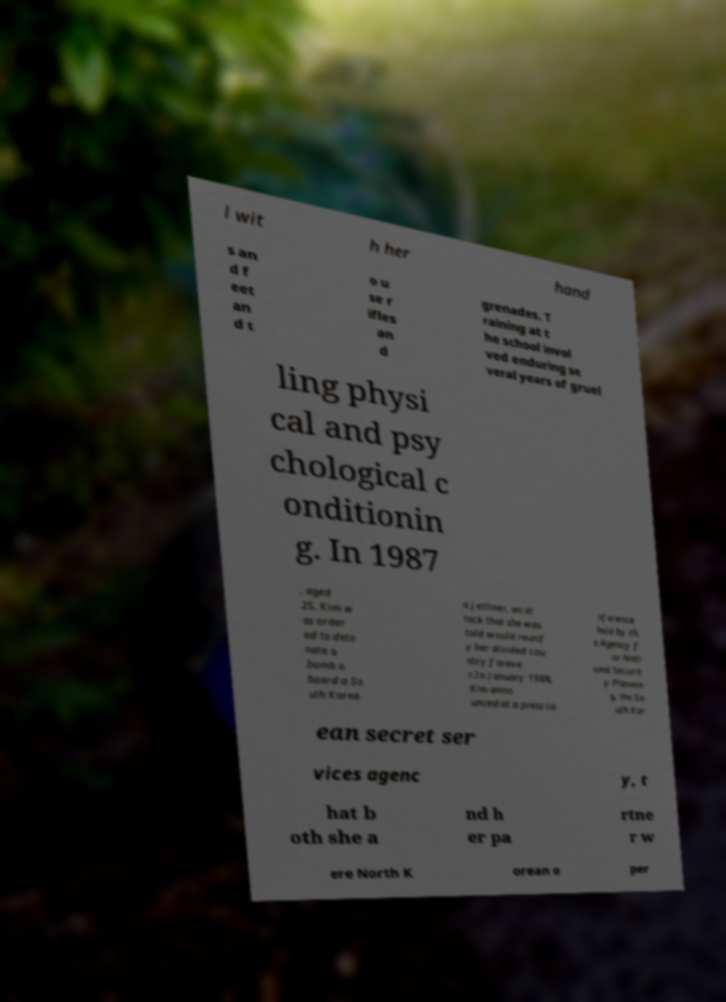I need the written content from this picture converted into text. Can you do that? l wit h her hand s an d f eet an d t o u se r ifles an d grenades. T raining at t he school invol ved enduring se veral years of gruel ling physi cal and psy chological c onditionin g. In 1987 , aged 25, Kim w as order ed to deto nate a bomb a board a So uth Korea n jetliner, an at tack that she was told would reunif y her divided cou ntry foreve r.In January 1988, Kim anno unced at a press co nference held by th e Agency f or Nati onal Securit y Plannin g, the So uth Kor ean secret ser vices agenc y, t hat b oth she a nd h er pa rtne r w ere North K orean o per 